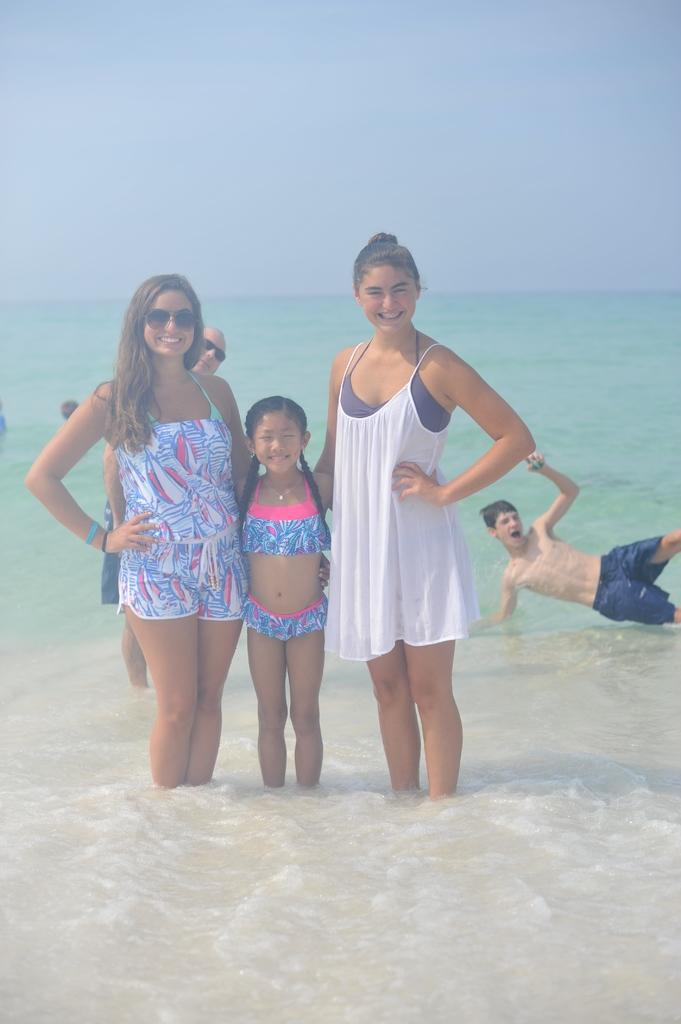How many people are present in the image? There are two women, a girl, and a boy in the image, making a total of four people. What is the background of the image? The background of the image is an ocean. Can you describe the positions of the people in the image? There are two women, one standing and the other sitting, a girl standing, and a boy on the right side of the image. What type of crime is being committed in the image? There is no crime being committed in the image; it features four people in front of an ocean. How many waves can be seen in the image? The image does not show any waves; it only shows the ocean as the background. 